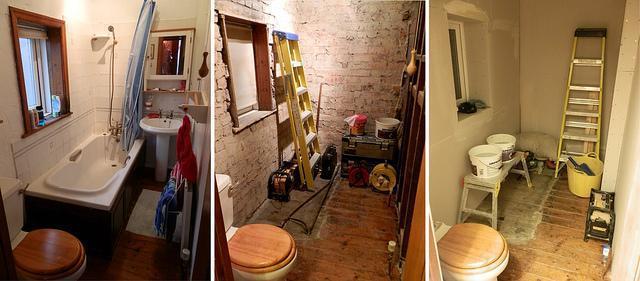How many white buckets are there?
Give a very brief answer. 3. How many toilets are in the picture?
Give a very brief answer. 3. How many men are there?
Give a very brief answer. 0. 